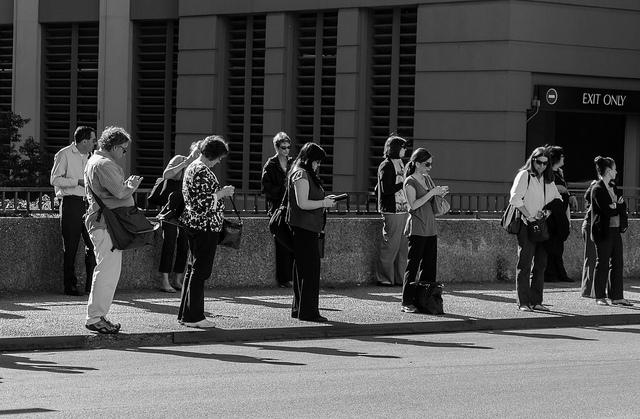What are the people likely doing? Please explain your reasoning. waiting. The people are standing on the side of the road because they are waiting for a bus. 